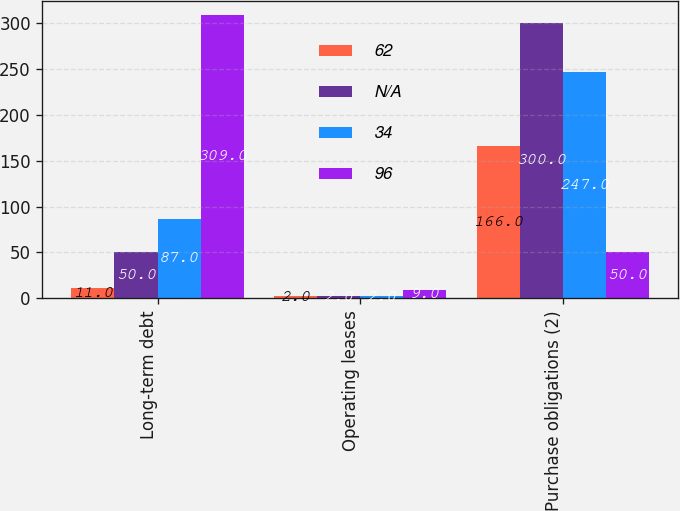Convert chart to OTSL. <chart><loc_0><loc_0><loc_500><loc_500><stacked_bar_chart><ecel><fcel>Long-term debt<fcel>Operating leases<fcel>Purchase obligations (2)<nl><fcel>62<fcel>11<fcel>2<fcel>166<nl><fcel>nan<fcel>50<fcel>2<fcel>300<nl><fcel>34<fcel>87<fcel>2<fcel>247<nl><fcel>96<fcel>309<fcel>9<fcel>50<nl></chart> 